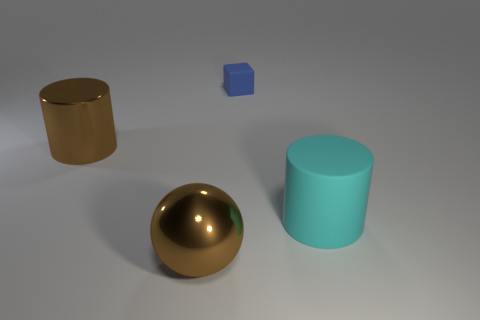There is a cylinder that is the same color as the ball; what is its size?
Provide a succinct answer. Large. Are there fewer cyan cylinders on the right side of the metallic ball than things in front of the brown cylinder?
Keep it short and to the point. Yes. Are there fewer brown metallic balls that are in front of the tiny blue matte cube than big cylinders?
Your answer should be very brief. Yes. What is the material of the big cylinder that is to the right of the large shiny object that is in front of the large cylinder to the right of the tiny matte object?
Your answer should be compact. Rubber. How many objects are big brown metallic objects on the right side of the metal cylinder or things to the right of the block?
Keep it short and to the point. 2. What number of shiny objects are brown objects or small green cubes?
Offer a very short reply. 2. What shape is the brown object that is made of the same material as the brown cylinder?
Your response must be concise. Sphere. How many other big rubber things are the same shape as the blue thing?
Your answer should be compact. 0. Does the matte object that is in front of the tiny rubber cube have the same shape as the rubber object to the left of the large cyan matte cylinder?
Offer a very short reply. No. How many things are either small cyan metallic objects or brown things behind the cyan rubber object?
Your answer should be very brief. 1. 